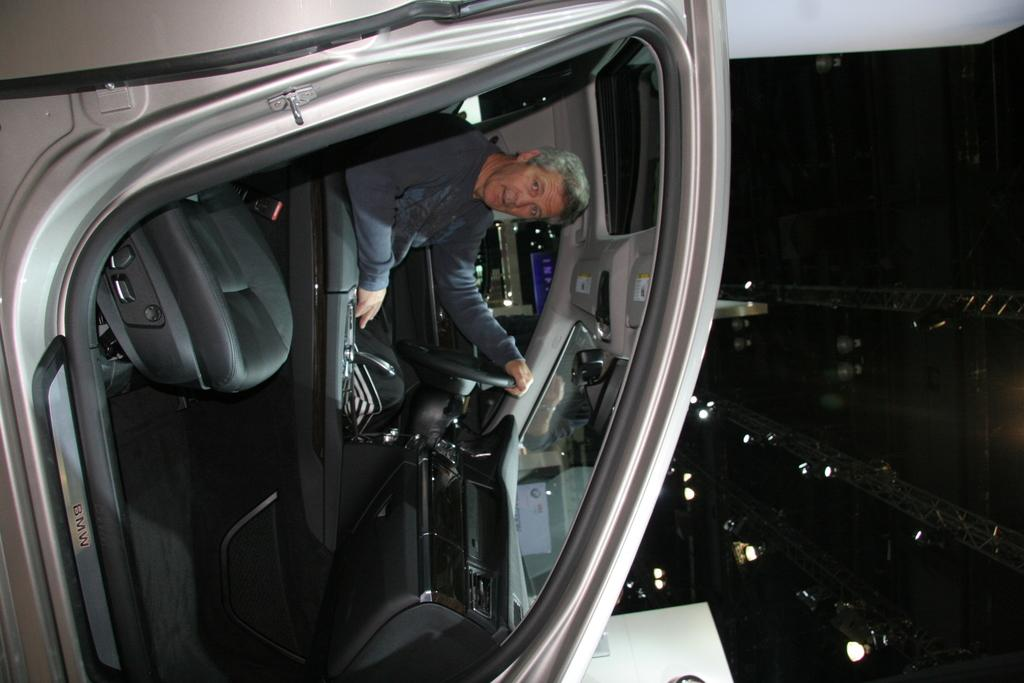What is present in the vehicle in the image? There is a person in the vehicle. Can you describe the person's position or activity in the vehicle? The provided facts do not give information about the person's position or activity in the vehicle. What type of vehicle is the person in? The provided facts do not specify the type of vehicle. What type of bike is hanging on the wall in the image? There is no bike present in the image; it only shows a person in a vehicle. 